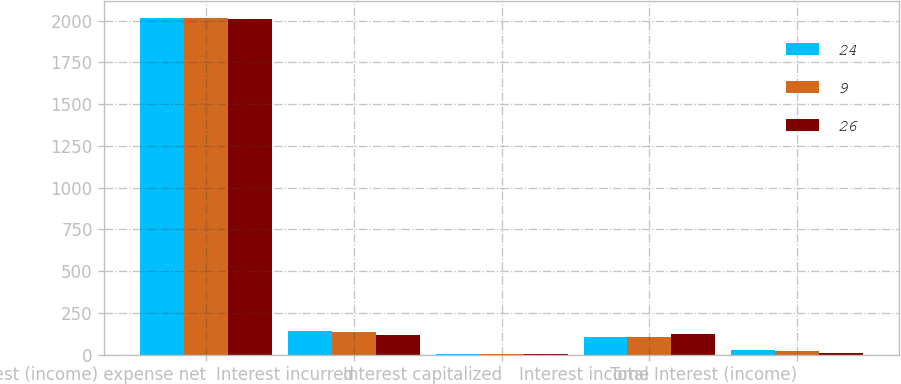Convert chart. <chart><loc_0><loc_0><loc_500><loc_500><stacked_bar_chart><ecel><fcel>Interest (income) expense net<fcel>Interest incurred<fcel>Interest capitalized<fcel>Interest income<fcel>Total Interest (income)<nl><fcel>24<fcel>2015<fcel>139<fcel>6<fcel>107<fcel>26<nl><fcel>9<fcel>2014<fcel>134<fcel>4<fcel>106<fcel>24<nl><fcel>26<fcel>2013<fcel>119<fcel>3<fcel>125<fcel>9<nl></chart> 